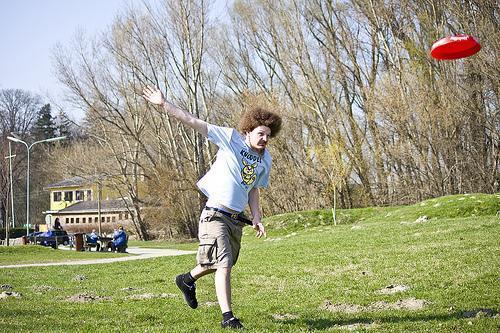How many people are the focus of the picture?
Give a very brief answer. 1. 